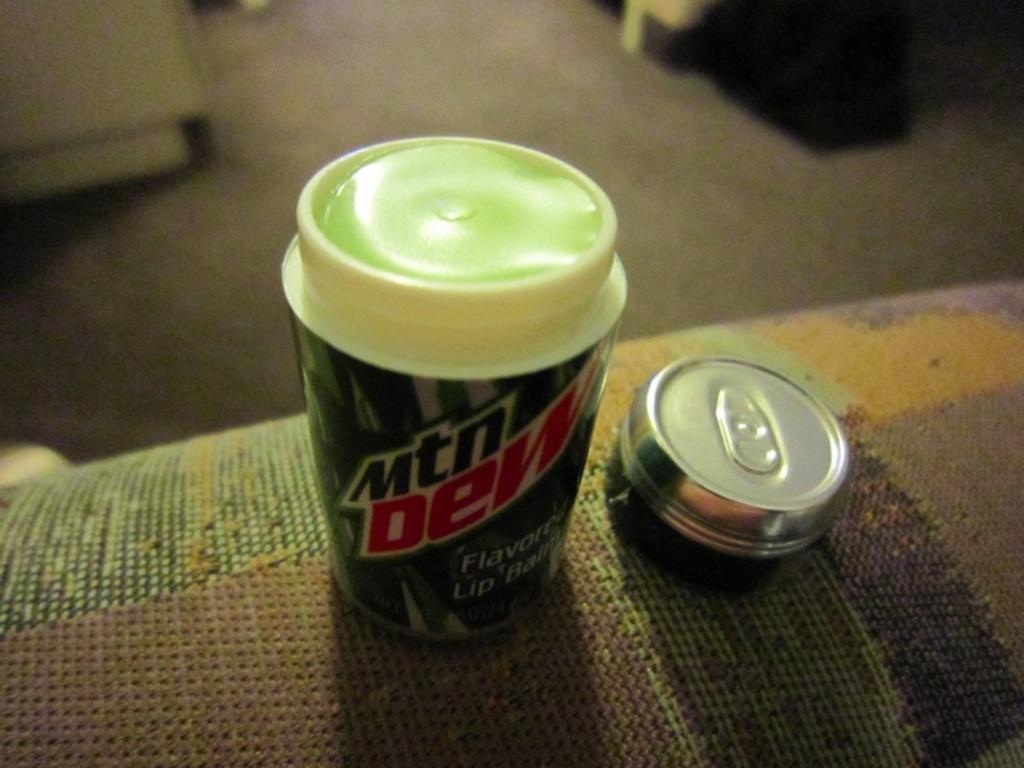What is the name of this soda?
Give a very brief answer. Mtn dew. Is there anyone in the background?
Your answer should be very brief. Answering does not require reading text in the image. 